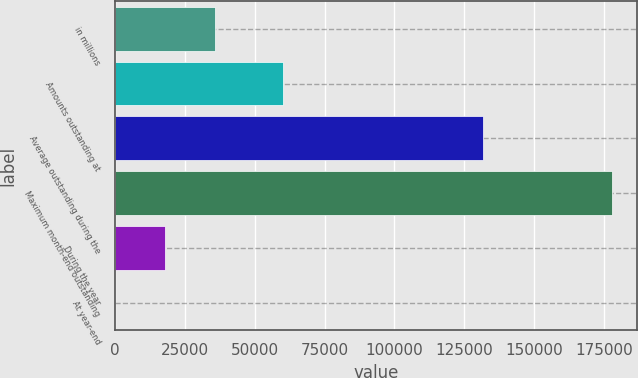<chart> <loc_0><loc_0><loc_500><loc_500><bar_chart><fcel>in millions<fcel>Amounts outstanding at<fcel>Average outstanding during the<fcel>Maximum month-end outstanding<fcel>During the year<fcel>At year-end<nl><fcel>35610.1<fcel>60099<fcel>131911<fcel>178049<fcel>17805.2<fcel>0.31<nl></chart> 